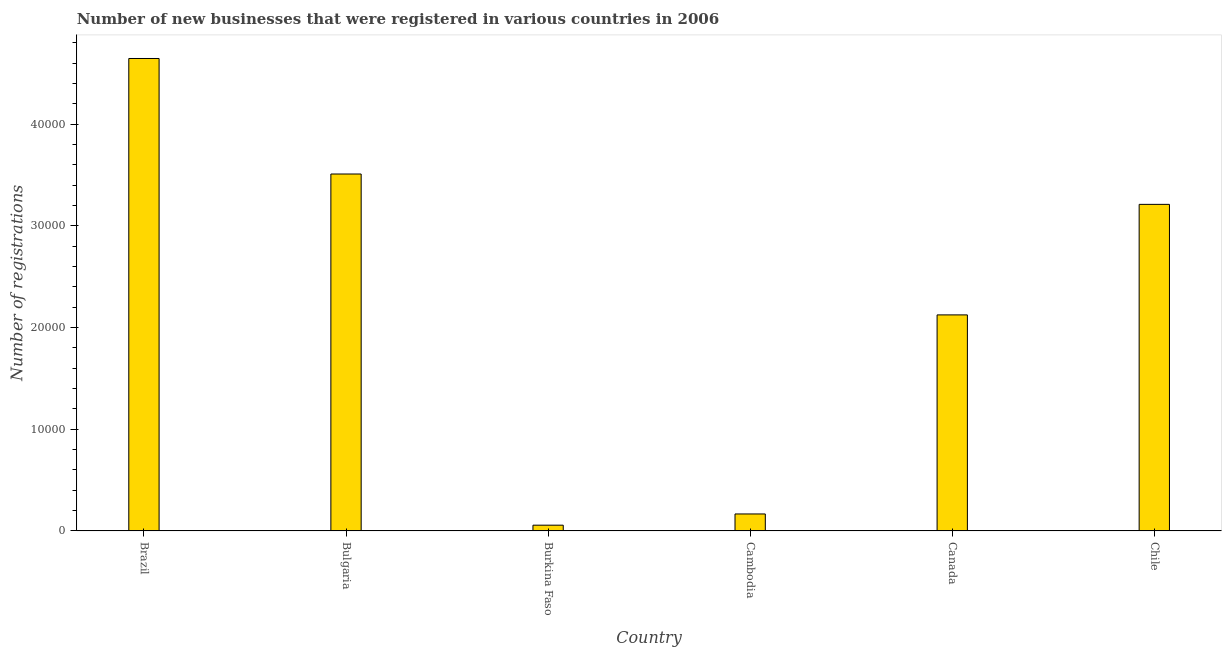Does the graph contain any zero values?
Your response must be concise. No. What is the title of the graph?
Your response must be concise. Number of new businesses that were registered in various countries in 2006. What is the label or title of the Y-axis?
Make the answer very short. Number of registrations. What is the number of new business registrations in Cambodia?
Make the answer very short. 1670. Across all countries, what is the maximum number of new business registrations?
Offer a very short reply. 4.65e+04. Across all countries, what is the minimum number of new business registrations?
Keep it short and to the point. 567. In which country was the number of new business registrations minimum?
Keep it short and to the point. Burkina Faso. What is the sum of the number of new business registrations?
Make the answer very short. 1.37e+05. What is the difference between the number of new business registrations in Brazil and Canada?
Provide a succinct answer. 2.52e+04. What is the average number of new business registrations per country?
Make the answer very short. 2.29e+04. What is the median number of new business registrations?
Your answer should be compact. 2.67e+04. What is the ratio of the number of new business registrations in Bulgaria to that in Burkina Faso?
Your answer should be very brief. 61.9. Is the number of new business registrations in Burkina Faso less than that in Chile?
Make the answer very short. Yes. What is the difference between the highest and the second highest number of new business registrations?
Give a very brief answer. 1.14e+04. What is the difference between the highest and the lowest number of new business registrations?
Offer a very short reply. 4.59e+04. How many countries are there in the graph?
Provide a succinct answer. 6. What is the difference between two consecutive major ticks on the Y-axis?
Offer a terse response. 10000. Are the values on the major ticks of Y-axis written in scientific E-notation?
Make the answer very short. No. What is the Number of registrations of Brazil?
Ensure brevity in your answer.  4.65e+04. What is the Number of registrations of Bulgaria?
Offer a very short reply. 3.51e+04. What is the Number of registrations in Burkina Faso?
Provide a short and direct response. 567. What is the Number of registrations of Cambodia?
Offer a terse response. 1670. What is the Number of registrations of Canada?
Offer a very short reply. 2.12e+04. What is the Number of registrations in Chile?
Your answer should be compact. 3.21e+04. What is the difference between the Number of registrations in Brazil and Bulgaria?
Offer a very short reply. 1.14e+04. What is the difference between the Number of registrations in Brazil and Burkina Faso?
Provide a succinct answer. 4.59e+04. What is the difference between the Number of registrations in Brazil and Cambodia?
Offer a terse response. 4.48e+04. What is the difference between the Number of registrations in Brazil and Canada?
Your answer should be compact. 2.52e+04. What is the difference between the Number of registrations in Brazil and Chile?
Keep it short and to the point. 1.43e+04. What is the difference between the Number of registrations in Bulgaria and Burkina Faso?
Keep it short and to the point. 3.45e+04. What is the difference between the Number of registrations in Bulgaria and Cambodia?
Your response must be concise. 3.34e+04. What is the difference between the Number of registrations in Bulgaria and Canada?
Your answer should be compact. 1.39e+04. What is the difference between the Number of registrations in Bulgaria and Chile?
Your response must be concise. 2986. What is the difference between the Number of registrations in Burkina Faso and Cambodia?
Your answer should be compact. -1103. What is the difference between the Number of registrations in Burkina Faso and Canada?
Make the answer very short. -2.07e+04. What is the difference between the Number of registrations in Burkina Faso and Chile?
Give a very brief answer. -3.15e+04. What is the difference between the Number of registrations in Cambodia and Canada?
Your answer should be very brief. -1.96e+04. What is the difference between the Number of registrations in Cambodia and Chile?
Your answer should be very brief. -3.04e+04. What is the difference between the Number of registrations in Canada and Chile?
Offer a terse response. -1.09e+04. What is the ratio of the Number of registrations in Brazil to that in Bulgaria?
Your answer should be compact. 1.32. What is the ratio of the Number of registrations in Brazil to that in Burkina Faso?
Offer a very short reply. 81.93. What is the ratio of the Number of registrations in Brazil to that in Cambodia?
Provide a short and direct response. 27.82. What is the ratio of the Number of registrations in Brazil to that in Canada?
Keep it short and to the point. 2.19. What is the ratio of the Number of registrations in Brazil to that in Chile?
Make the answer very short. 1.45. What is the ratio of the Number of registrations in Bulgaria to that in Burkina Faso?
Give a very brief answer. 61.9. What is the ratio of the Number of registrations in Bulgaria to that in Cambodia?
Your answer should be compact. 21.02. What is the ratio of the Number of registrations in Bulgaria to that in Canada?
Offer a terse response. 1.65. What is the ratio of the Number of registrations in Bulgaria to that in Chile?
Offer a terse response. 1.09. What is the ratio of the Number of registrations in Burkina Faso to that in Cambodia?
Offer a terse response. 0.34. What is the ratio of the Number of registrations in Burkina Faso to that in Canada?
Offer a very short reply. 0.03. What is the ratio of the Number of registrations in Burkina Faso to that in Chile?
Provide a succinct answer. 0.02. What is the ratio of the Number of registrations in Cambodia to that in Canada?
Keep it short and to the point. 0.08. What is the ratio of the Number of registrations in Cambodia to that in Chile?
Your answer should be very brief. 0.05. What is the ratio of the Number of registrations in Canada to that in Chile?
Offer a very short reply. 0.66. 